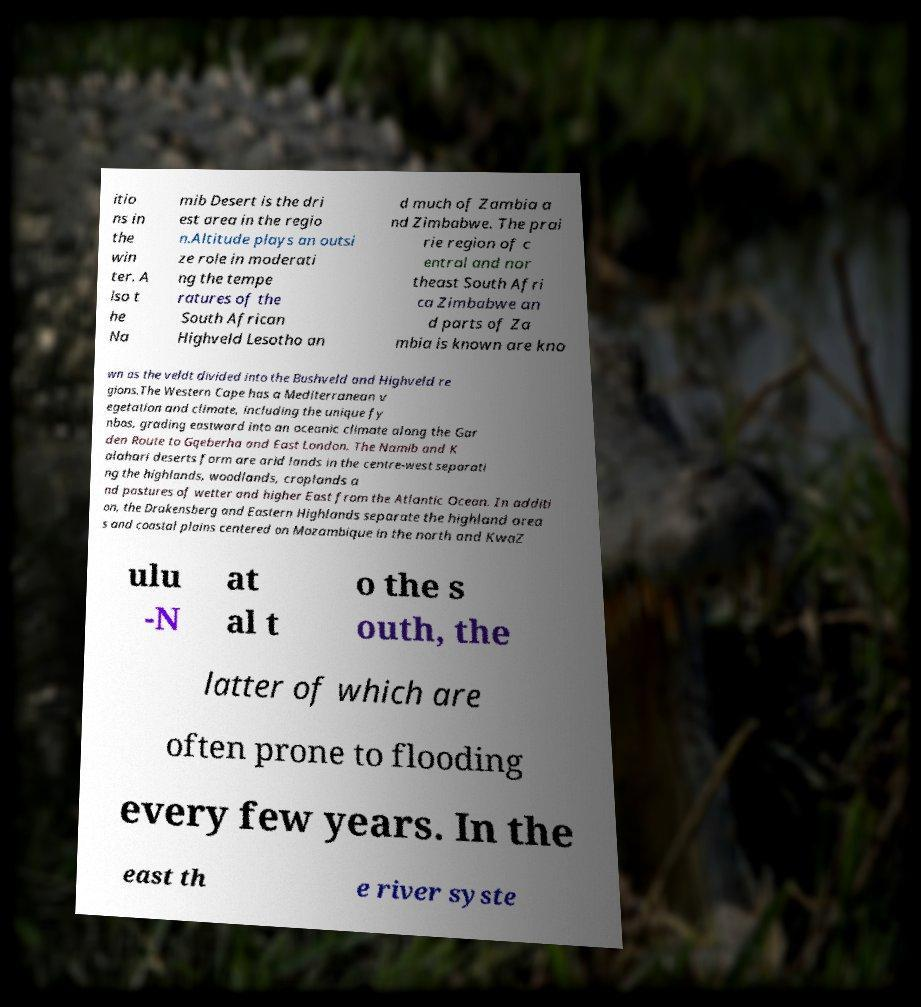Please identify and transcribe the text found in this image. itio ns in the win ter. A lso t he Na mib Desert is the dri est area in the regio n.Altitude plays an outsi ze role in moderati ng the tempe ratures of the South African Highveld Lesotho an d much of Zambia a nd Zimbabwe. The prai rie region of c entral and nor theast South Afri ca Zimbabwe an d parts of Za mbia is known are kno wn as the veldt divided into the Bushveld and Highveld re gions.The Western Cape has a Mediterranean v egetation and climate, including the unique fy nbos, grading eastward into an oceanic climate along the Gar den Route to Gqeberha and East London. The Namib and K alahari deserts form are arid lands in the centre-west separati ng the highlands, woodlands, croplands a nd pastures of wetter and higher East from the Atlantic Ocean. In additi on, the Drakensberg and Eastern Highlands separate the highland area s and coastal plains centered on Mozambique in the north and KwaZ ulu -N at al t o the s outh, the latter of which are often prone to flooding every few years. In the east th e river syste 